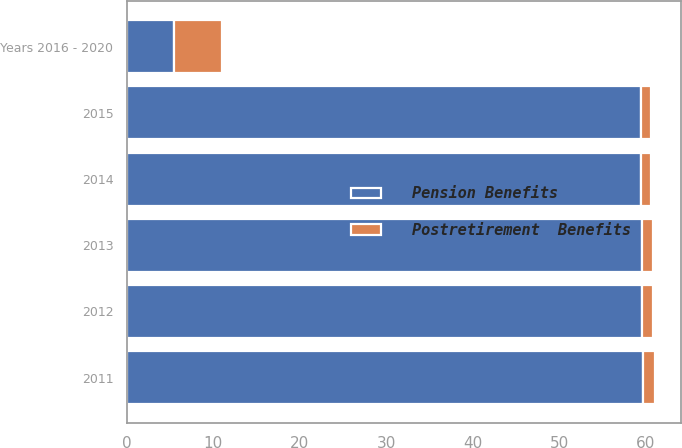Convert chart to OTSL. <chart><loc_0><loc_0><loc_500><loc_500><stacked_bar_chart><ecel><fcel>2011<fcel>2012<fcel>2013<fcel>2014<fcel>2015<fcel>Years 2016 - 2020<nl><fcel>Pension Benefits<fcel>59.7<fcel>59.5<fcel>59.5<fcel>59.4<fcel>59.4<fcel>5.5<nl><fcel>Postretirement  Benefits<fcel>1.3<fcel>1.3<fcel>1.3<fcel>1.2<fcel>1.2<fcel>5.5<nl></chart> 